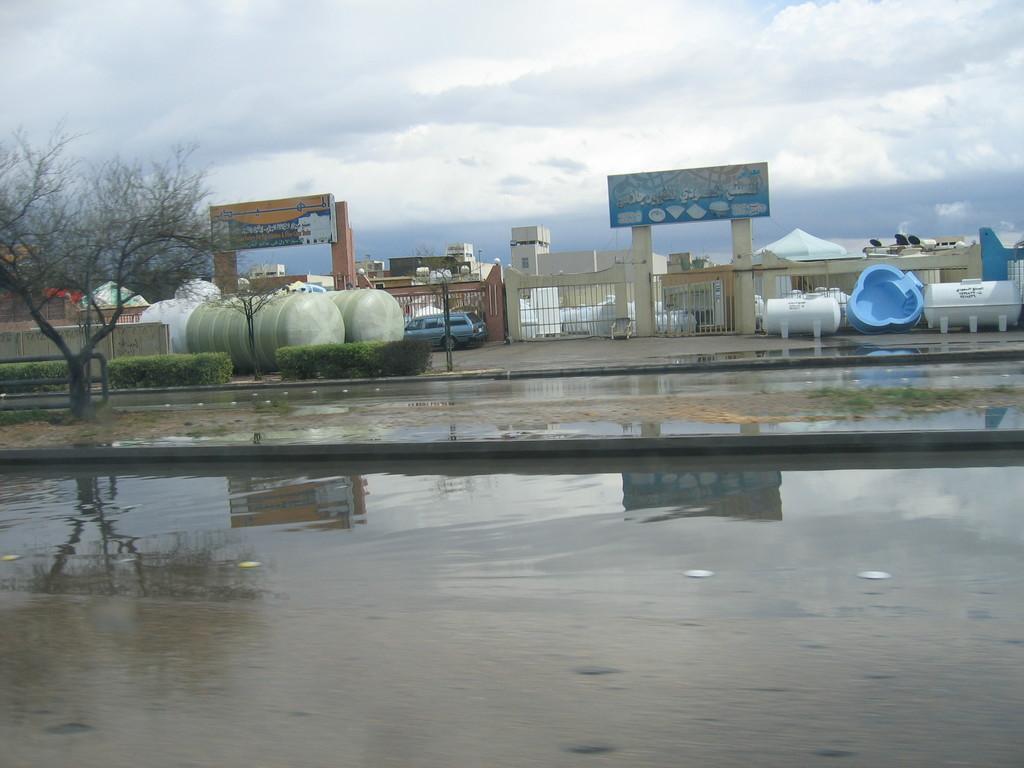Please provide a concise description of this image. In the center of the image there are buildings and we can see containers. There are boards. On the left there are trees and hedges. In the background there is sky. At the bottom there is water. 